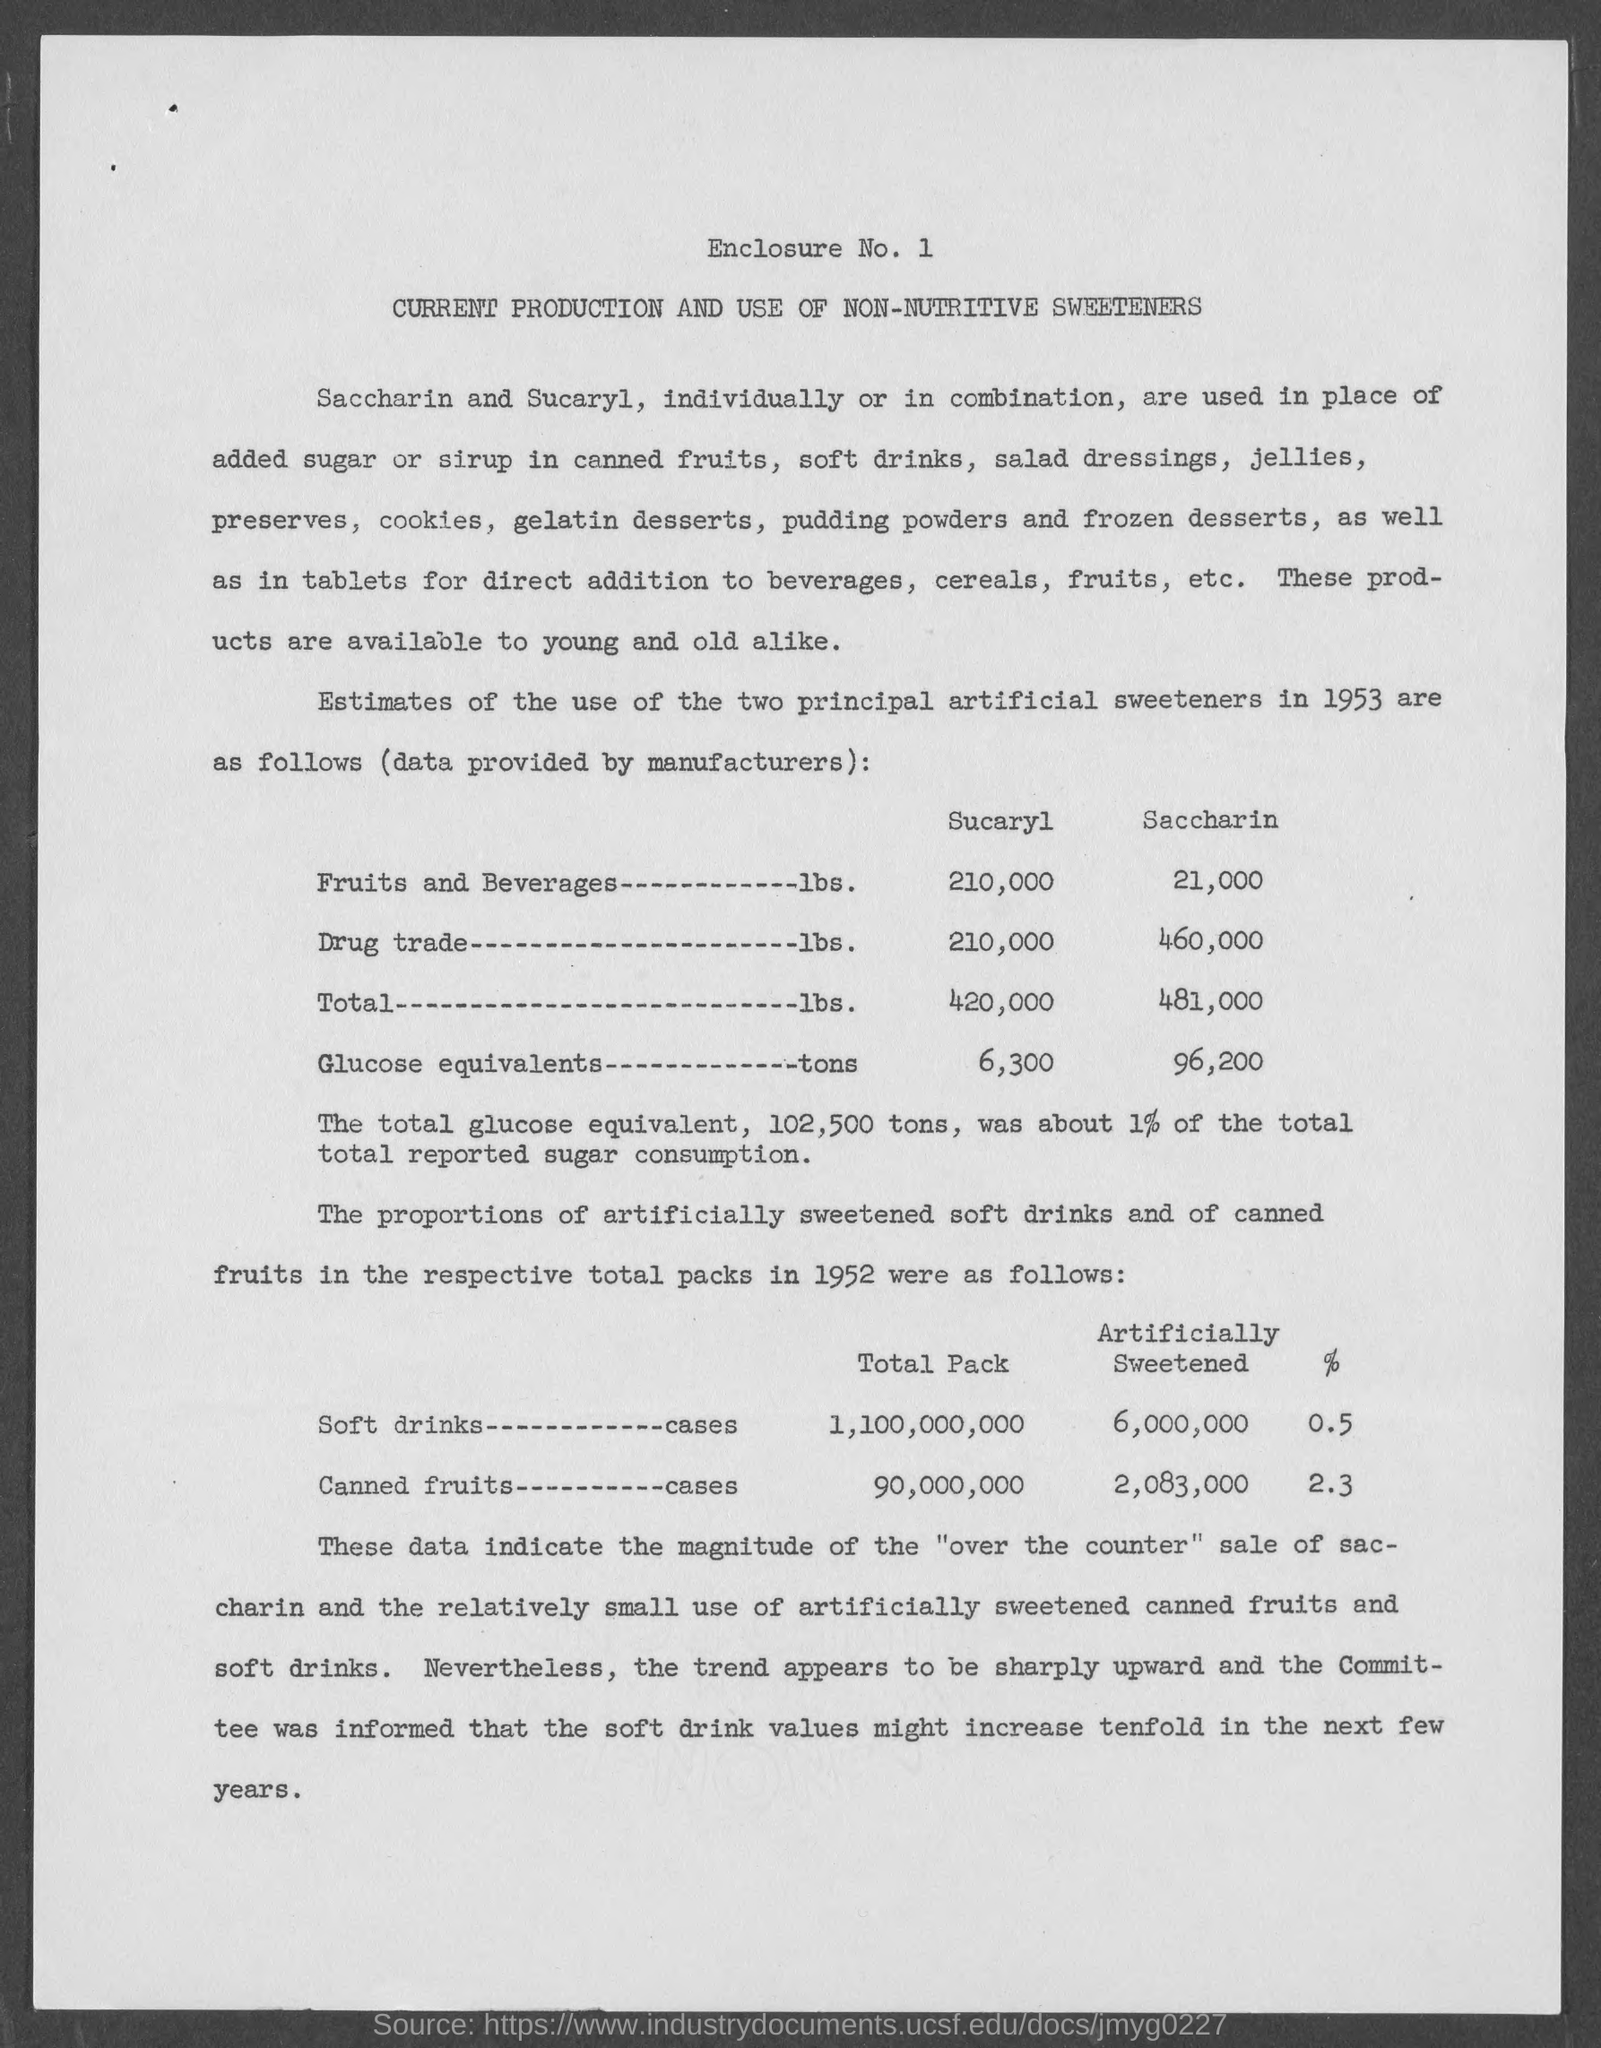List a handful of essential elements in this visual. The quantity of Sucaryl in 6,300 Glucose Equivalents is [objective]. Approximately 1% of the total reported sugar consumption in the United States is equivalent to 102,500 tons of total glucose equivalent. Approximately 210,000 pounds of Sucaryl is added to fruits and beverages. The amount of saccharin in glucose equivalents is 96,200. 